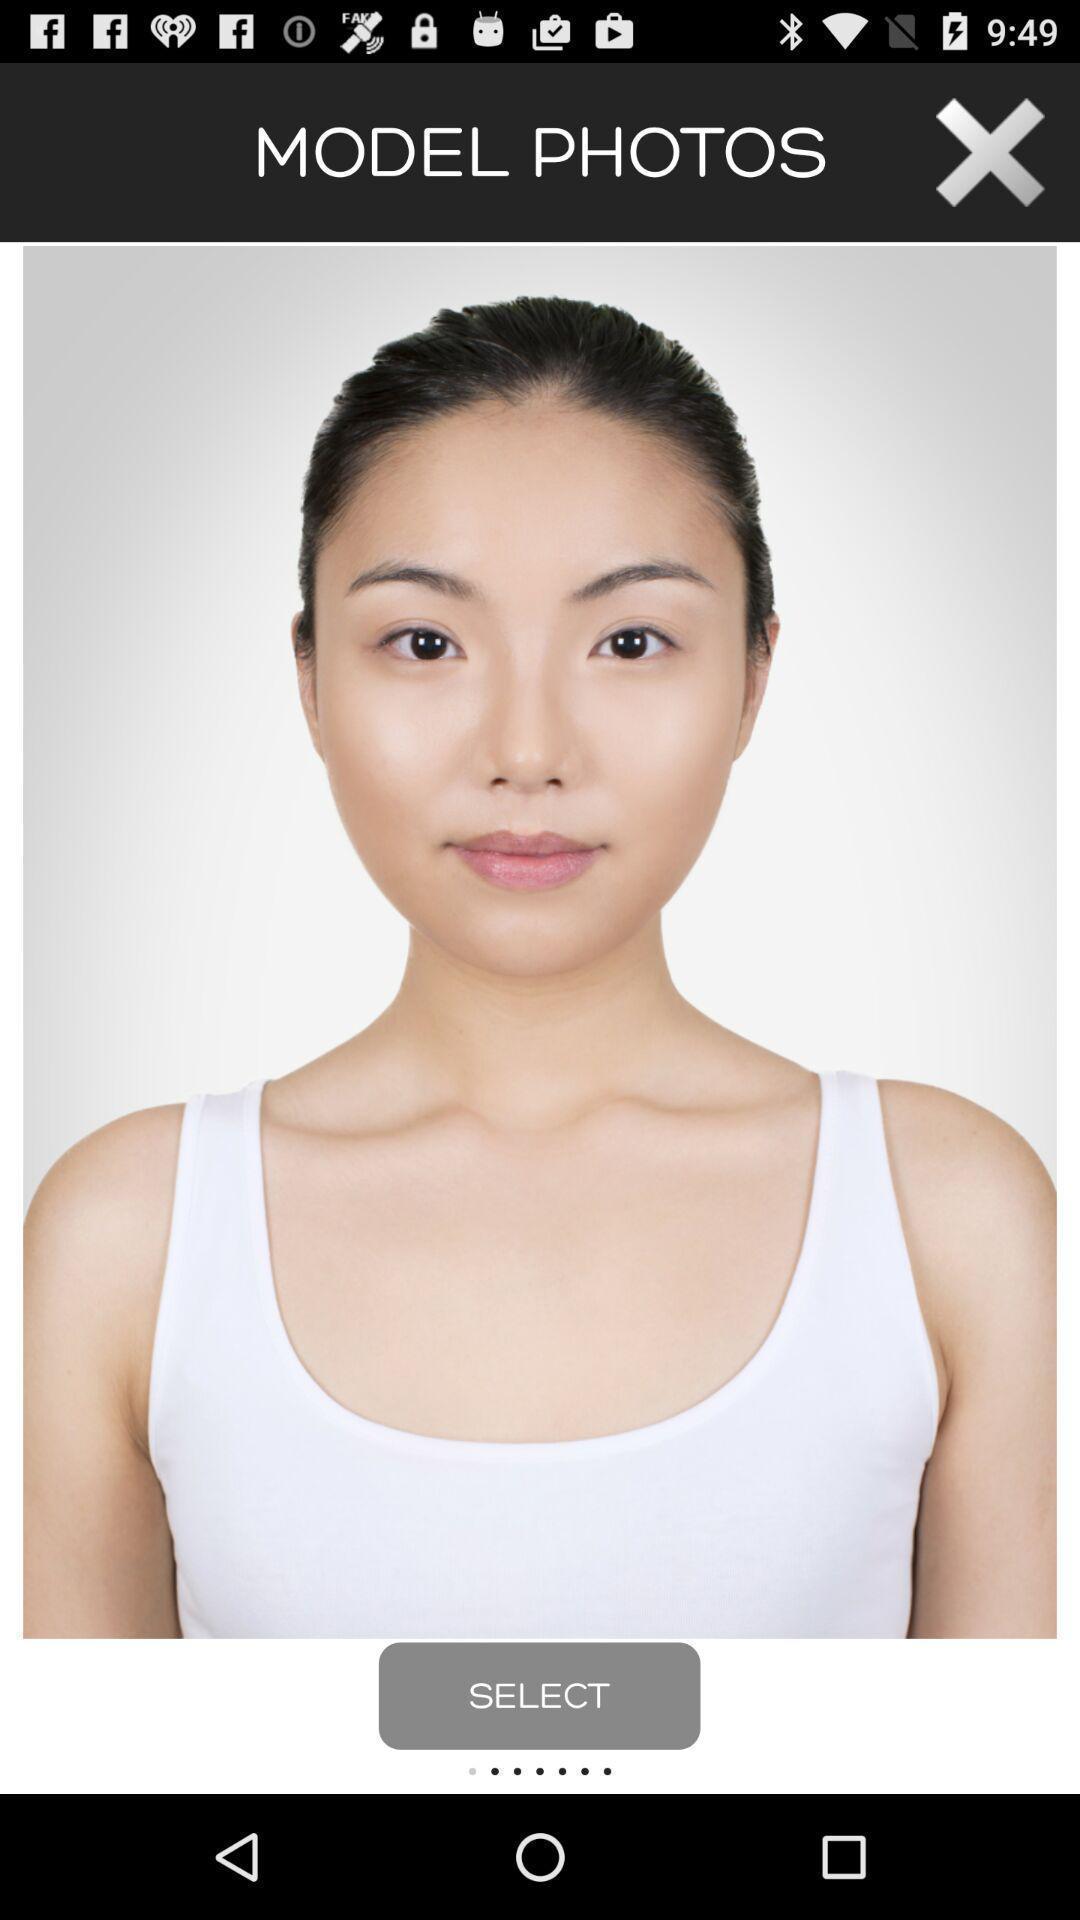Tell me about the visual elements in this screen capture. Picture of a person in a modelling app. 